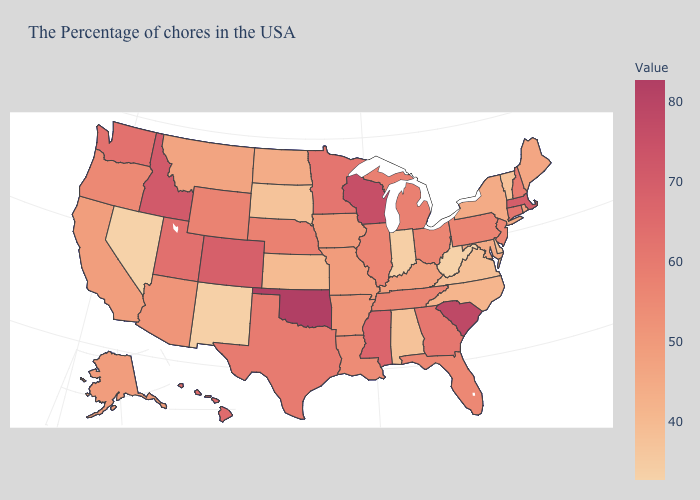Which states have the lowest value in the USA?
Answer briefly. West Virginia, Nevada. Among the states that border Minnesota , does Wisconsin have the highest value?
Write a very short answer. Yes. Which states have the highest value in the USA?
Short answer required. Oklahoma. Which states have the lowest value in the USA?
Short answer required. West Virginia, Nevada. Which states have the lowest value in the USA?
Write a very short answer. West Virginia, Nevada. Does Maine have a lower value than Mississippi?
Give a very brief answer. Yes. 